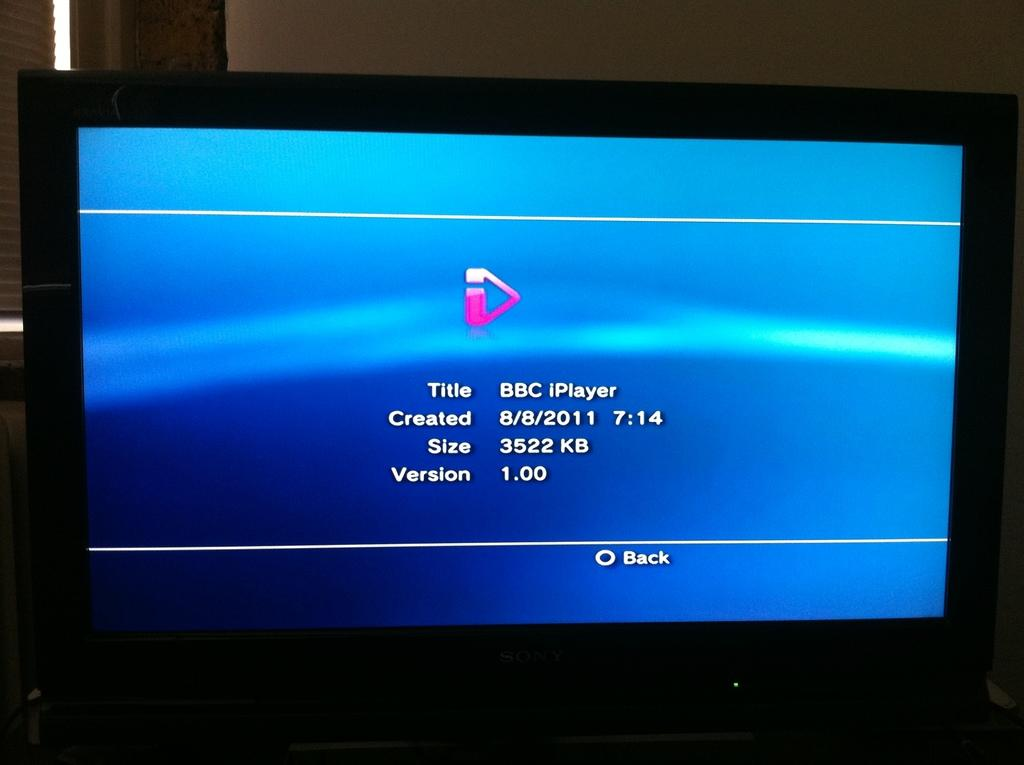<image>
Relay a brief, clear account of the picture shown. the word title on the main screen of a video console 